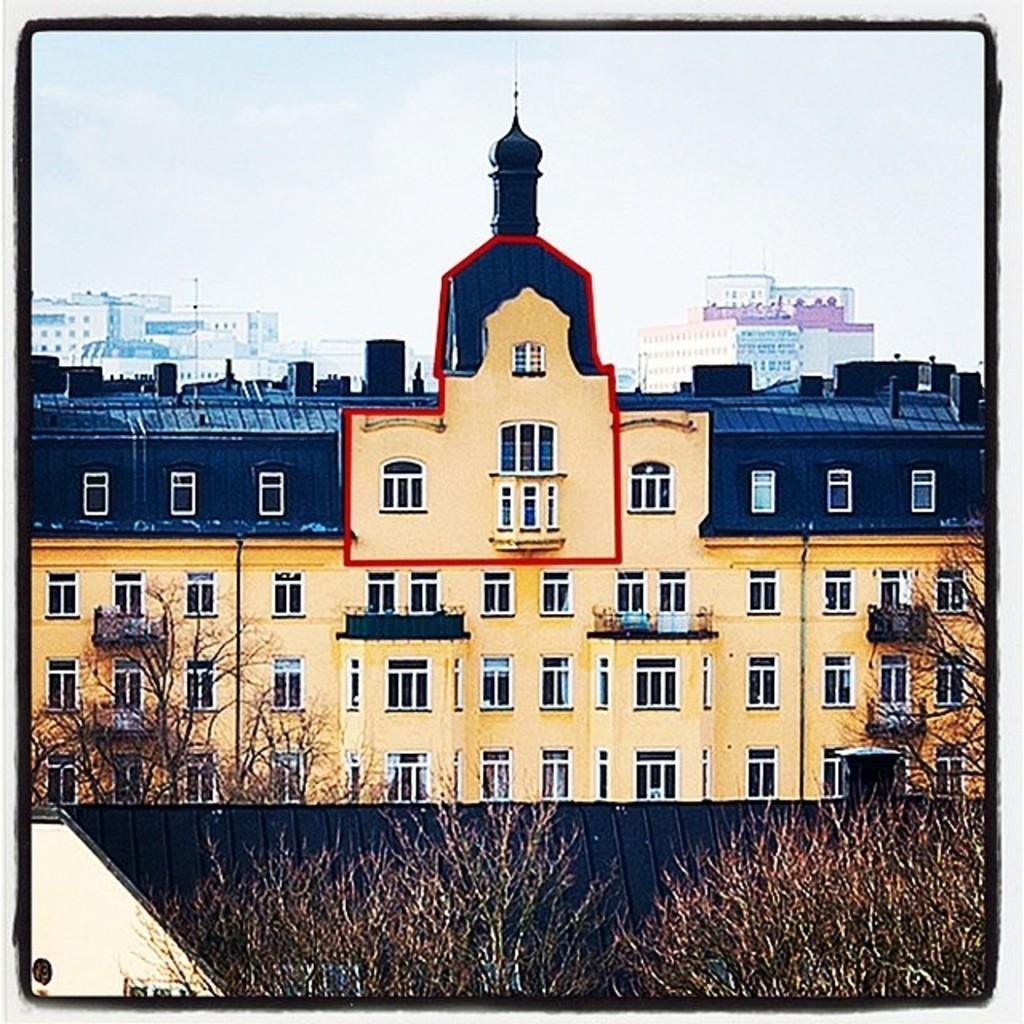What type of structures can be seen in the image? There are buildings in the image. What feature is present on the buildings? There are windows in the image. What type of vegetation is visible in the image? There are trees in the image. What is visible at the top of the image? The sky is visible at the top of the image. Can you tell me how many snakes are slithering on the windows in the image? There are no snakes present in the image; it features buildings, windows, trees, and the sky. What is the chance of finding a fingerprint on the windows in the image? There is no information about fingerprints or their likelihood on the windows in the image. 